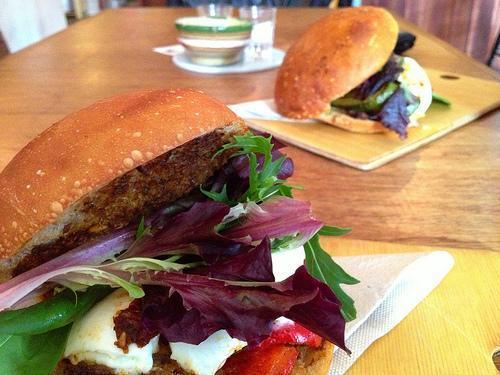How many yellow placemats are there?
Give a very brief answer. 2. How many burgers are there?
Give a very brief answer. 2. 